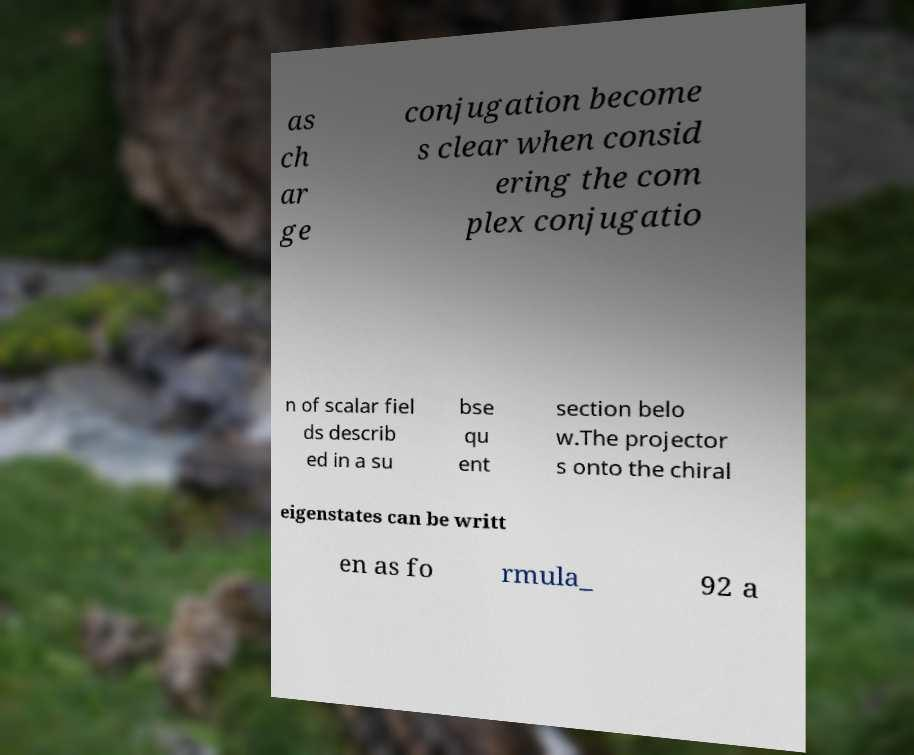Can you accurately transcribe the text from the provided image for me? as ch ar ge conjugation become s clear when consid ering the com plex conjugatio n of scalar fiel ds describ ed in a su bse qu ent section belo w.The projector s onto the chiral eigenstates can be writt en as fo rmula_ 92 a 